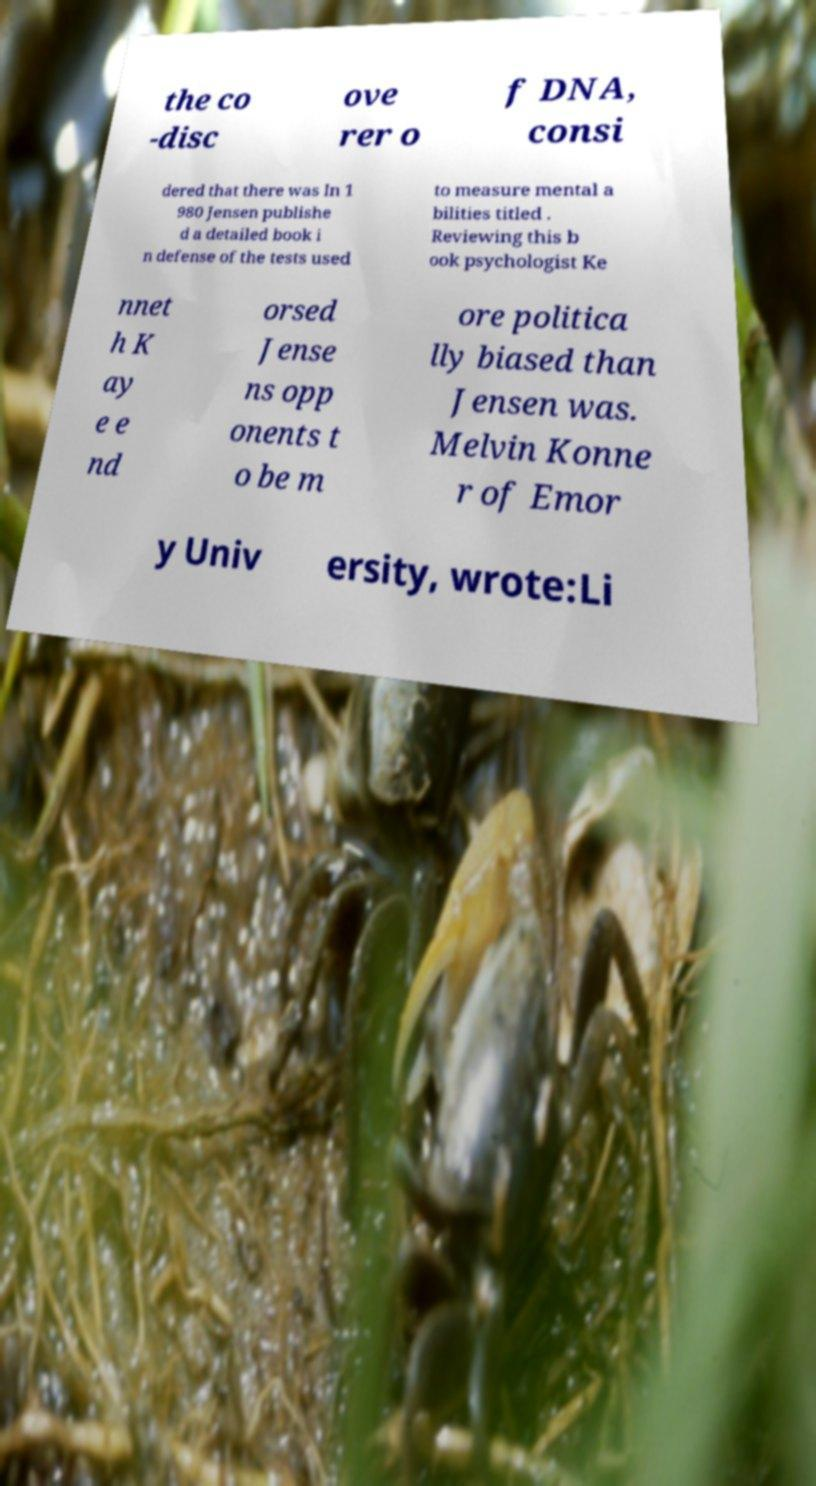I need the written content from this picture converted into text. Can you do that? the co -disc ove rer o f DNA, consi dered that there was In 1 980 Jensen publishe d a detailed book i n defense of the tests used to measure mental a bilities titled . Reviewing this b ook psychologist Ke nnet h K ay e e nd orsed Jense ns opp onents t o be m ore politica lly biased than Jensen was. Melvin Konne r of Emor y Univ ersity, wrote:Li 